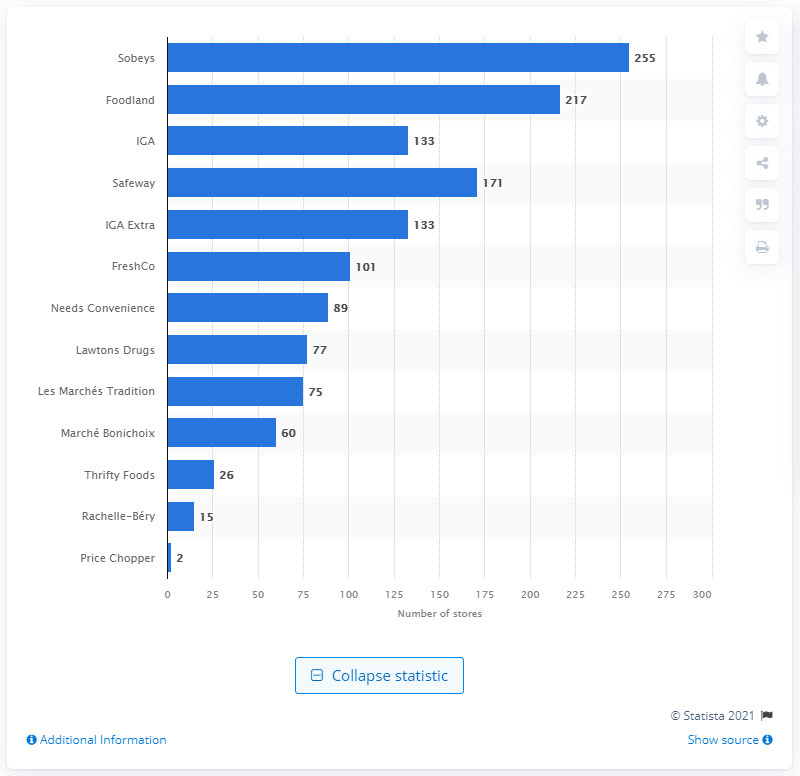Highlight a few significant elements in this photo. In April 2021, there were 255 Sobeys retail stores in Canada. 